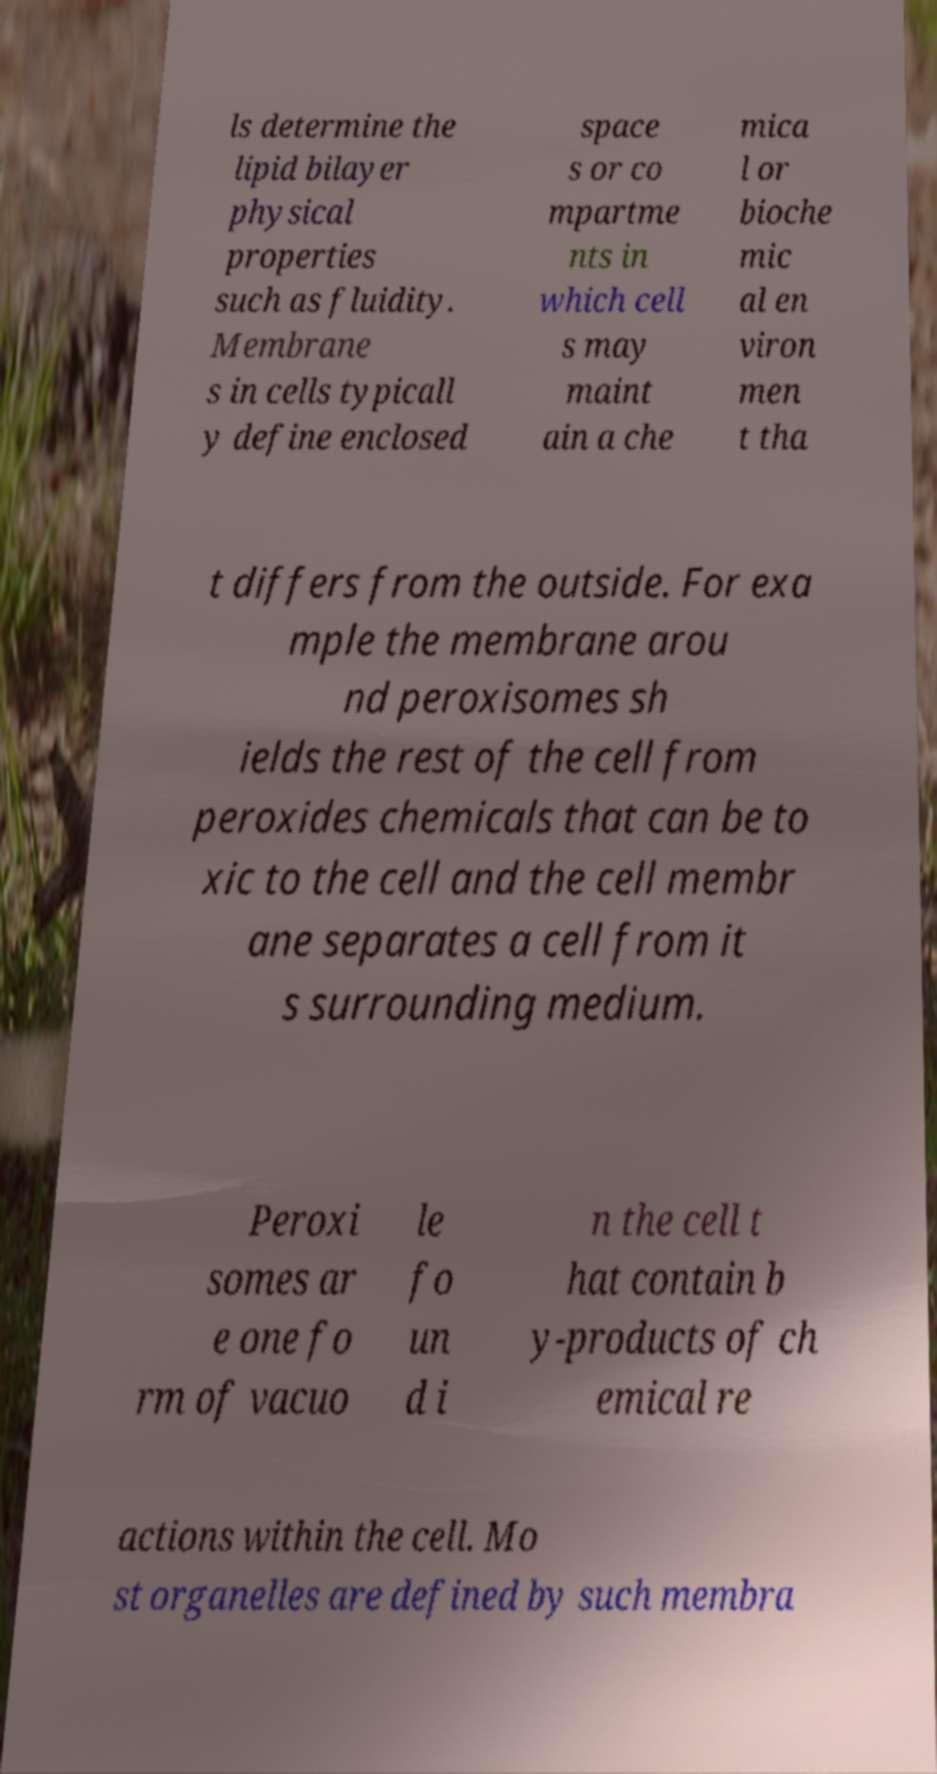There's text embedded in this image that I need extracted. Can you transcribe it verbatim? ls determine the lipid bilayer physical properties such as fluidity. Membrane s in cells typicall y define enclosed space s or co mpartme nts in which cell s may maint ain a che mica l or bioche mic al en viron men t tha t differs from the outside. For exa mple the membrane arou nd peroxisomes sh ields the rest of the cell from peroxides chemicals that can be to xic to the cell and the cell membr ane separates a cell from it s surrounding medium. Peroxi somes ar e one fo rm of vacuo le fo un d i n the cell t hat contain b y-products of ch emical re actions within the cell. Mo st organelles are defined by such membra 